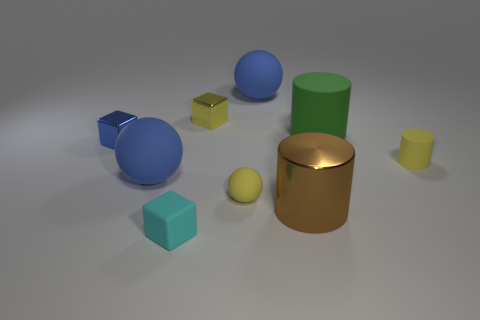There is a tiny yellow rubber cylinder; are there any rubber cylinders to the left of it?
Give a very brief answer. Yes. Is there a cylinder of the same color as the tiny sphere?
Give a very brief answer. Yes. How many tiny objects are brown metal things or yellow metal objects?
Your answer should be compact. 1. Is the large object left of the cyan thing made of the same material as the cyan cube?
Offer a terse response. Yes. What shape is the big blue object that is right of the blue thing that is in front of the yellow matte thing that is on the right side of the shiny cylinder?
Ensure brevity in your answer.  Sphere. What number of blue objects are either rubber blocks or small cylinders?
Give a very brief answer. 0. Are there an equal number of large blue matte balls that are right of the yellow cube and blue balls to the right of the tiny rubber ball?
Give a very brief answer. Yes. There is a tiny yellow matte object right of the yellow sphere; is it the same shape as the big object right of the brown shiny object?
Give a very brief answer. Yes. What shape is the big green object that is made of the same material as the tiny cyan cube?
Make the answer very short. Cylinder. Is the number of small yellow rubber things that are to the right of the small yellow rubber ball the same as the number of rubber cubes?
Provide a succinct answer. Yes. 